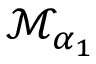<formula> <loc_0><loc_0><loc_500><loc_500>{ \mathcal { M } } _ { \alpha _ { 1 } }</formula> 